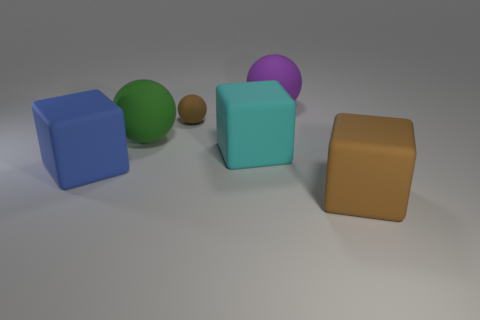There is a tiny ball that is made of the same material as the large blue block; what is its color?
Provide a succinct answer. Brown. Do the large blue matte object and the green matte object have the same shape?
Provide a succinct answer. No. Is there a tiny matte thing that is in front of the sphere to the left of the brown matte object behind the large brown object?
Make the answer very short. No. What number of big blocks are the same color as the small thing?
Your answer should be compact. 1. There is a cyan rubber thing that is the same size as the brown matte cube; what is its shape?
Provide a short and direct response. Cube. Are there any cyan blocks behind the purple rubber sphere?
Your response must be concise. No. Do the green matte ball and the brown cube have the same size?
Offer a terse response. Yes. What is the shape of the brown object in front of the big green ball?
Your answer should be compact. Cube. Is there a cyan cylinder that has the same size as the cyan matte object?
Make the answer very short. No. There is a purple thing that is the same size as the blue matte thing; what is it made of?
Provide a succinct answer. Rubber. 